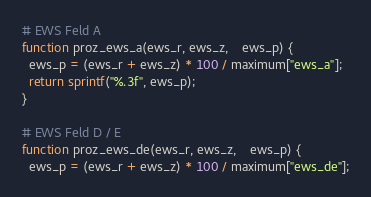Convert code to text. <code><loc_0><loc_0><loc_500><loc_500><_Awk_># EWS Feld A
function proz_ews_a(ews_r, ews_z,    ews_p) {
  ews_p = (ews_r + ews_z) * 100 / maximum["ews_a"];
  return sprintf("%.3f", ews_p);
}  

# EWS Feld D / E
function proz_ews_de(ews_r, ews_z,    ews_p) {
  ews_p = (ews_r + ews_z) * 100 / maximum["ews_de"];</code> 